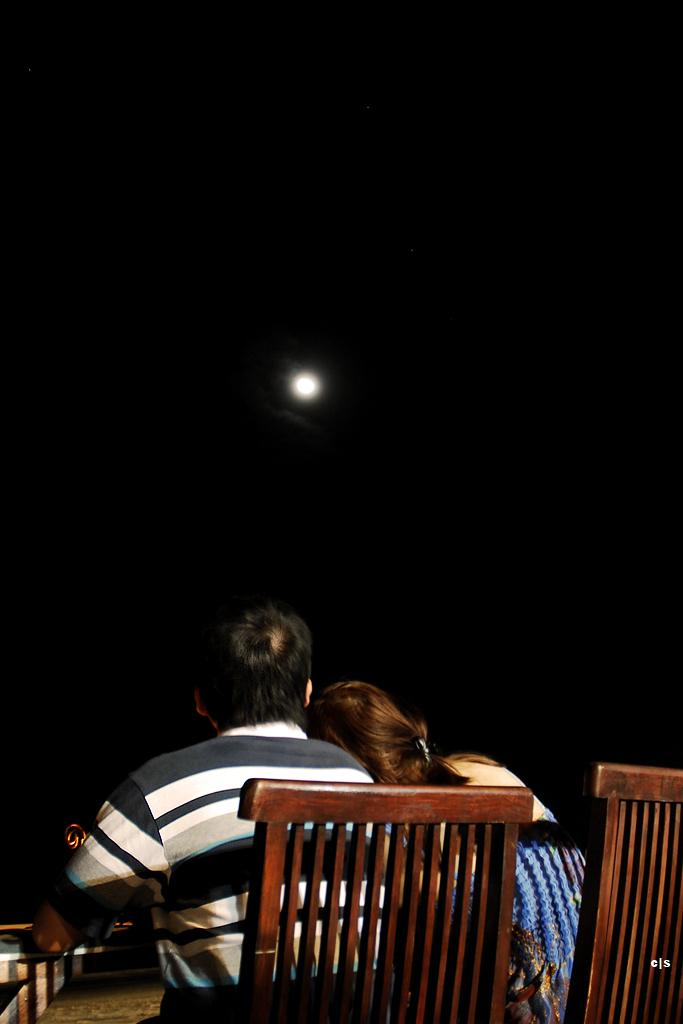Who can be seen in the image? There is a lady and a man in the image. What are the lady and the man doing in the image? They are sitting on chairs and watching the moon. Where is the rat in the image? There is no rat present in the image. What type of hall can be seen in the image? There is no hall present in the image. 